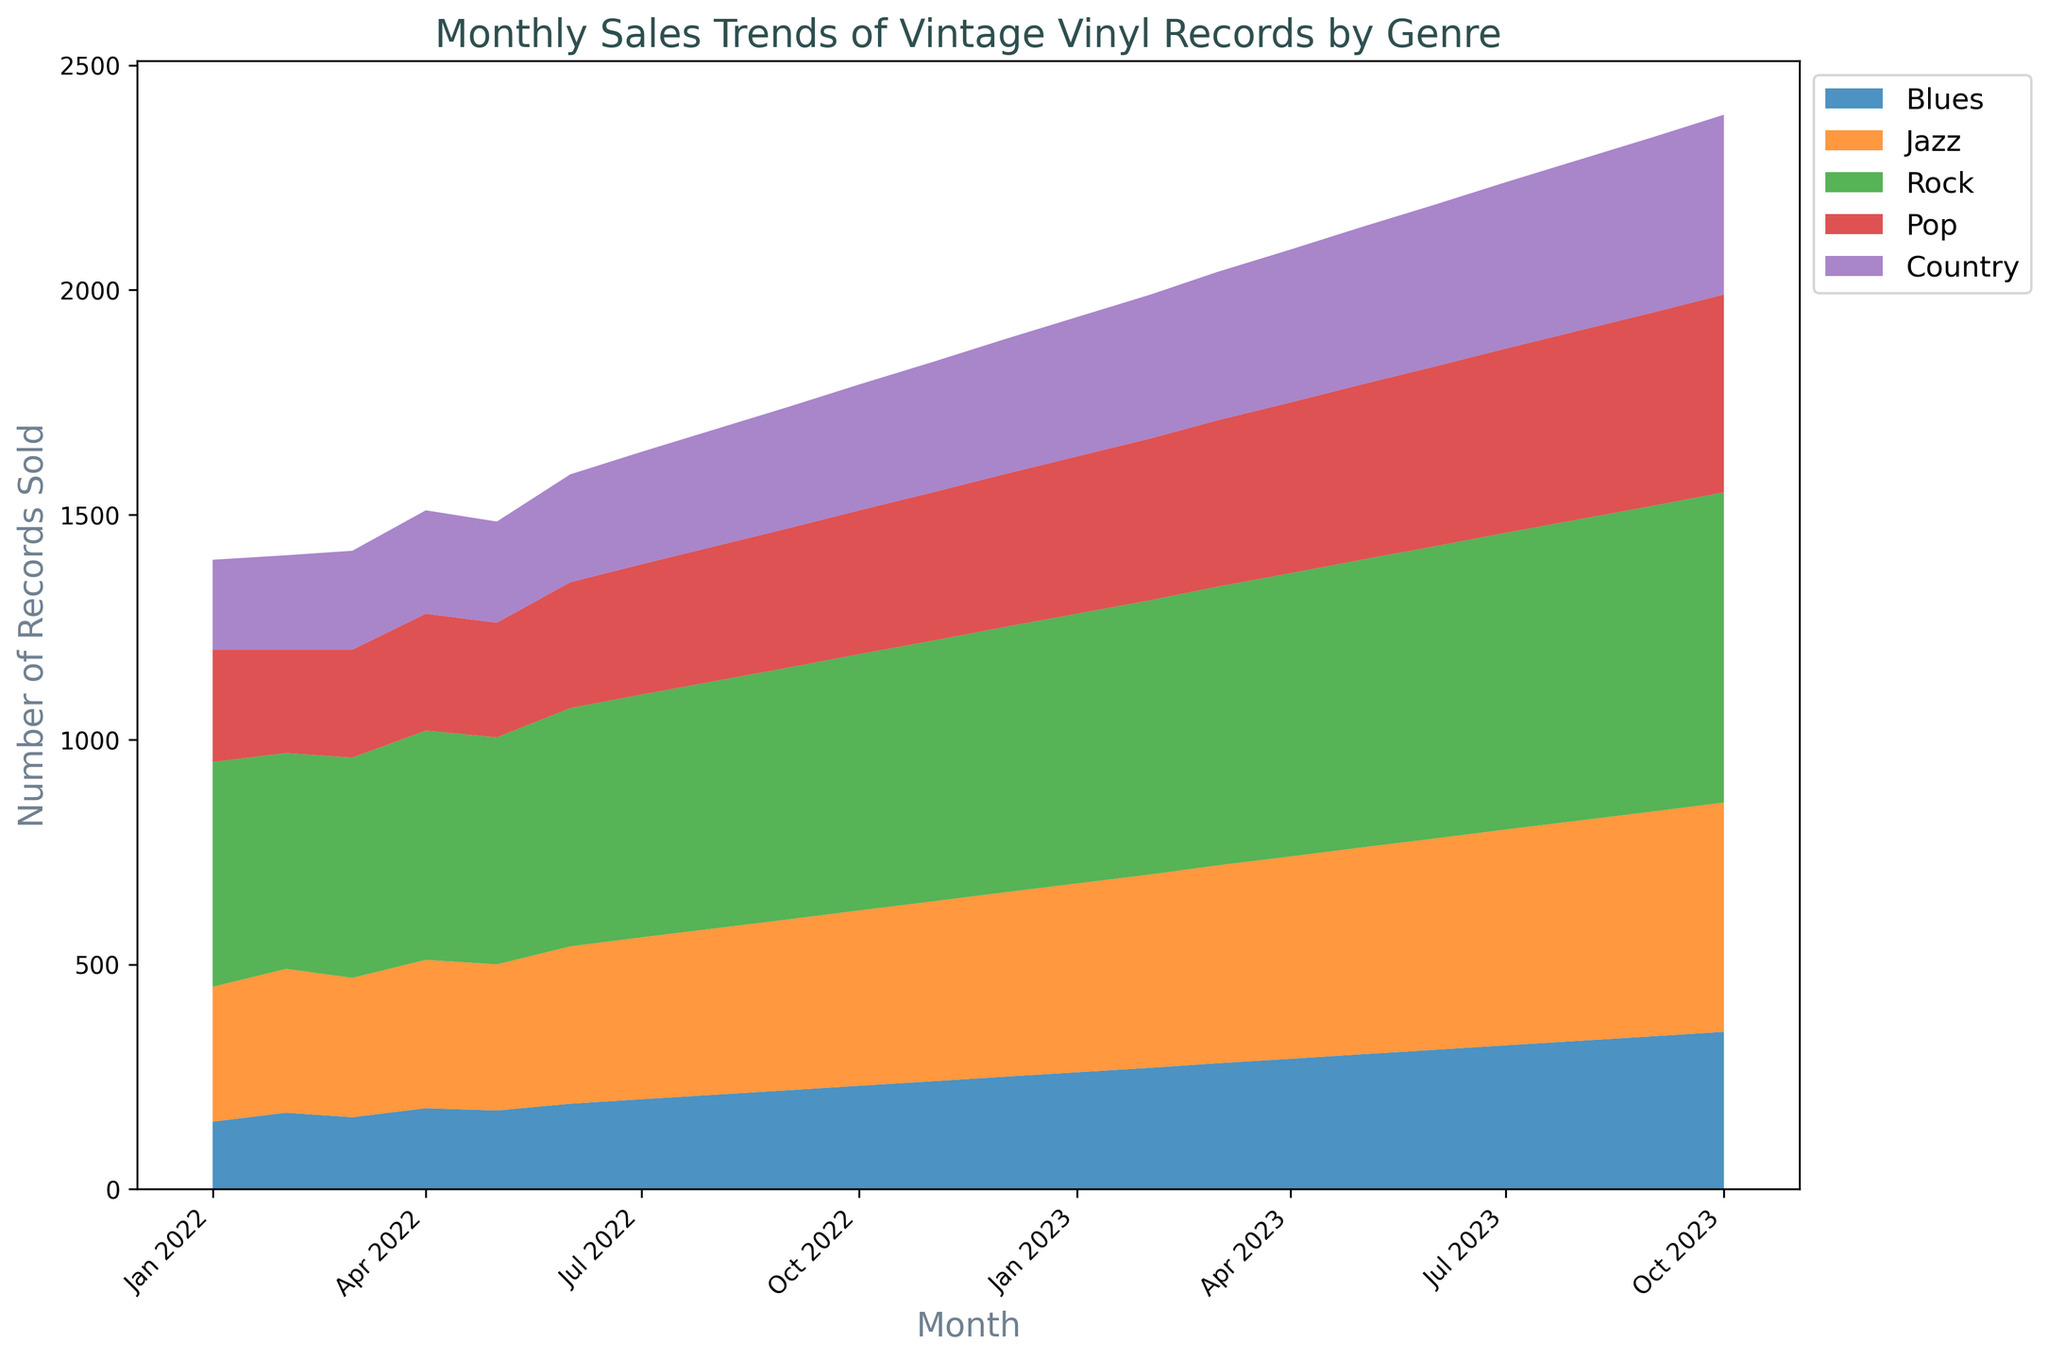What genre has the highest monthly sales in July 2023? To find the genre with the highest sales in July 2023, locate the sales values for that month and compare them: Blues (320), Jazz (480), Rock (660), Pop (410), Country (370). Rock has the highest value.
Answer: Rock Which genre's sales had the largest increase from January 2022 to October 2023? Calculate the difference in sales for each genre between January 2022 and October 2023: Blues (350-150=200), Jazz (510-300=210), Rock (690-500=190), Pop (440-250=190), Country (400-200=200). Jazz had the largest increase.
Answer: Jazz What is the average monthly sales of Blues records in 2023? Extract the Blues sales data for 2023: January (260), February (270), March (280), April (290), May (300), June (310), July (320), August (330), September (340), October (350). Average = (260+270+280+290+300+310+320+330+340+350)/10 = 305.
Answer: 305 Between Pop and Country, which genre has shown a more steady sales trend over the entire period? A steady trend indicates minimal fluctuations. Comparing the variations from month to month, Pop sales show fluctuations but a general increase, while Country sales show a similar trend. Visually, Country appears more consistent.
Answer: Country Compare the sales of Rock and Jazz in the first and the last month of the dataset. Which genre experienced a higher growth rate? For Rock: Initial (500), Final (690). Growth = 690-500 = 190. For Jazz: Initial (300), Final (510). Growth = 510-300 = 210. Jazz experienced a higher growth rate.
Answer: Jazz What was the highest monthly sales volume for any single genre over the entire period? By scanning the area plot, the highest peak corresponds to Rock in October 2023 with 690 records sold.
Answer: 690 Which month witnessed the highest combined sales for all genres together? Aggregate the sales of all genres for each month and identify the highest total. October 2023 has the highest combined sales: Blues (350) + Jazz (510) + Rock (690) + Pop (440) + Country (400) = 2390.
Answer: October 2023 In which month did Blues surpass Pop in sales for the first time? Locate the first month where Blues sales exceed those of Pop. January 2023: Blues (260), Pop (250).
Answer: January 2023 How does the trend in Jazz sales compare visually to the trend in Country sales? Both Jazz and Country sales increase over the period. Jazz shows a smoother, relatively steeper upward trend compared to Country, which increases steadily but more gradually.
Answer: Jazz sales show a smoother, steeper increase Summing up the first and last month's sales for Country, what do you get? For Country: First month (200), Last month (400). Sum = 200 + 400 = 600.
Answer: 600 